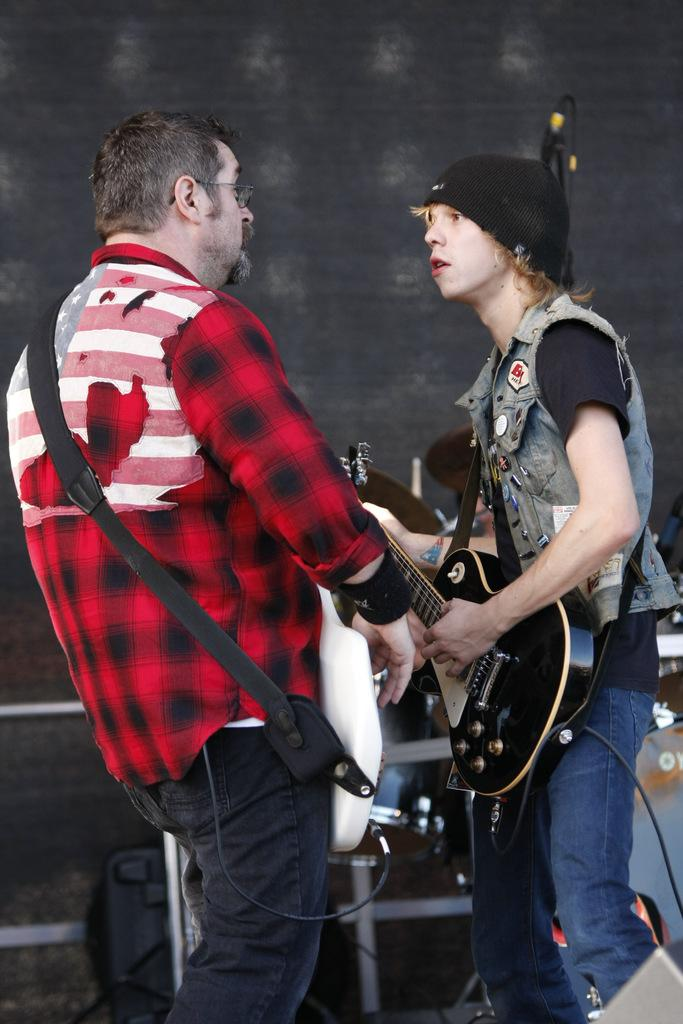How many people are in the image? There are two persons in the image. What are the two persons doing in the image? The two persons are standing. What objects are the two persons holding in their hands? Each person is holding a guitar in their hands. What type of dress is the beggar wearing in the image? There is no beggar present in the image, and therefore no dress can be observed. 